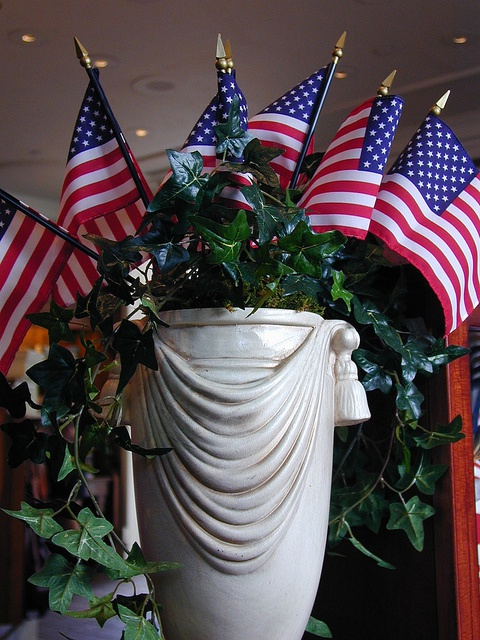Describe the objects in this image and their specific colors. I can see potted plant in maroon, black, lightgray, darkgray, and gray tones and vase in maroon, lightgray, darkgray, black, and gray tones in this image. 